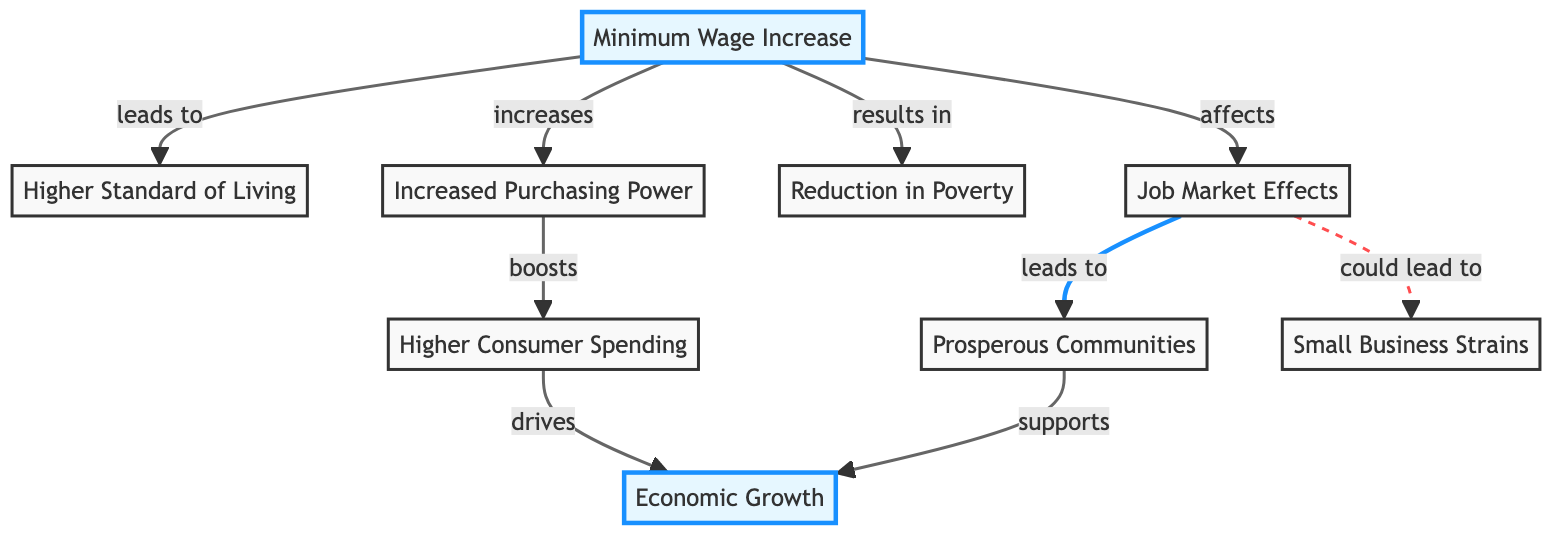What is the initial node in the flowchart? The flowchart begins with the "Minimum Wage Increase" node, which serves as the starting point for the flow of information regarding the impact of minimum wage changes.
Answer: Minimum Wage Increase How many primary outcomes are derived from the minimum wage increase? The diagram shows three primary outcomes from the "Minimum Wage Increase": "Higher Standard of Living," "Economic Growth," and "Lower Poverty." Therefore, the total count of outcomes is determined by identifying these distinct effects.
Answer: Three What effect does increased purchasing power have on consumer spending? "Increased Purchasing Power" leads to "Higher Consumer Spending," as shown in the diagram. This shows a direct relationship where one effect boosts the other.
Answer: Boosts Which node is connected to the "Job Market Effects" node? The "Job Market Effects" node connects to two other nodes: "Prosperous Communities" (indicating a positive effect) and "Small Business Strains" (noting a potential negative consequence). By examining the edges in the diagram, each connected output can be identified.
Answer: Prosperous Communities, Small Business Strains What is the relationship between "Higher Consumer Spending" and "Economic Growth"? The relationship shows that "Higher Consumer Spending" drives "Economic Growth," indicating a cause-and-effect situation where increased spending is linked to enhanced economic performance.
Answer: Drives What could potentially result from job market effects? The job market effects may lead to "Prosperous Communities," showcasing a positive outcome, but they could also lead to "Small Business Strains," presenting a possible negative effect, shown by the dashed line indicating a weaker connection.
Answer: Small Business Strains If minimum wage increases are implemented, what is one possible social outcome aligned with Sanders' principles? One possible social outcome would be "Reduction in Poverty," as indicated in the diagram, which is consistent with Sanders' advocacy for minimum wage increases as a means of improving living standards.
Answer: Reduction in Poverty How does a prosperous community affect economic growth? According to the diagram, "Prosperous Communities" support "Economic Growth," suggesting that thriving areas enhance overall economic performance. The flow communicates positive reinforcement where one outcome aids another.
Answer: Supports What is the consequence of increased purchasing power in the diagram? In the diagram, the consequence of increased purchasing power is the "Higher Consumer Spending," which follows directly from the purchasing power increase. This illustrates how financial capacity contributes to consumption levels.
Answer: Higher Consumer Spending 